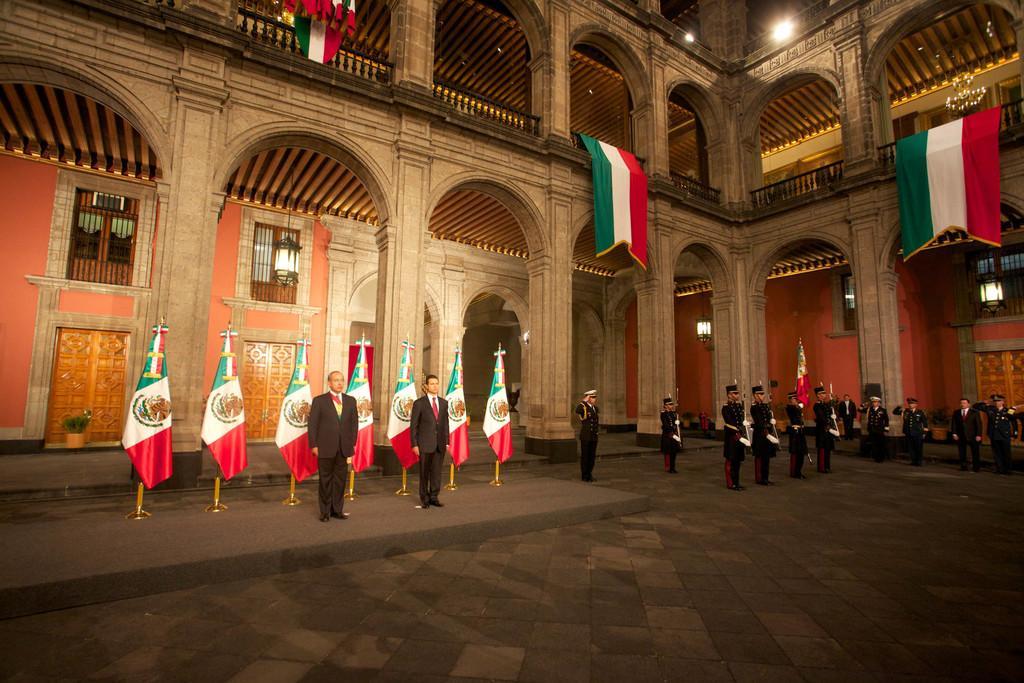Could you give a brief overview of what you see in this image? This image is taken in inside a building, in this image there are people standing in the background there are flags pillars, at the top there are flags. 